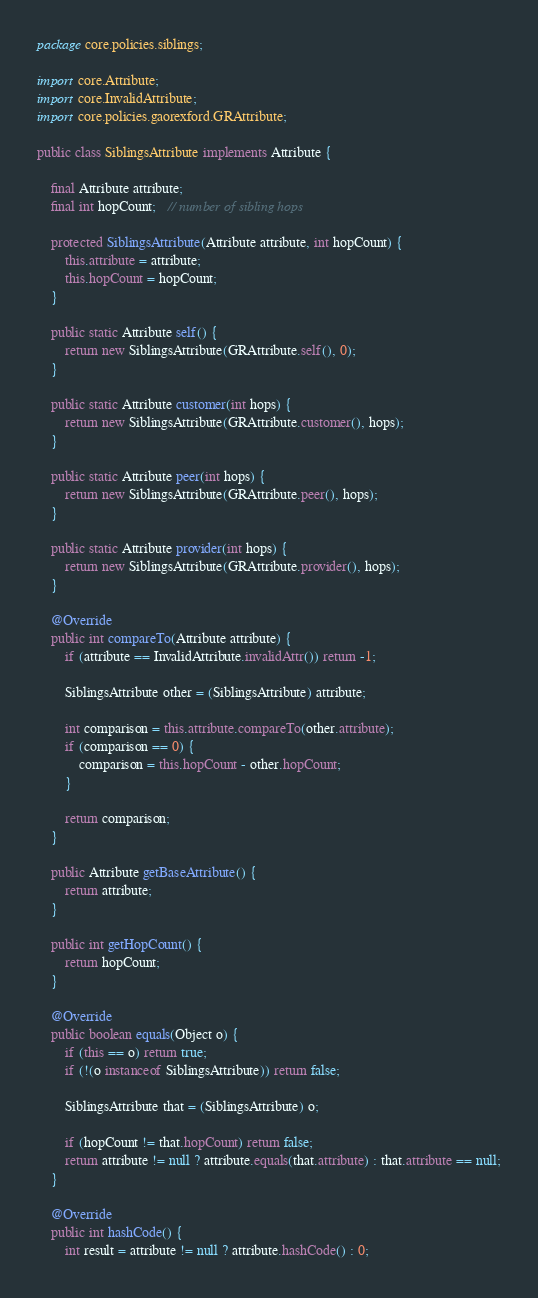Convert code to text. <code><loc_0><loc_0><loc_500><loc_500><_Java_>package core.policies.siblings;

import core.Attribute;
import core.InvalidAttribute;
import core.policies.gaorexford.GRAttribute;

public class SiblingsAttribute implements Attribute {

    final Attribute attribute;
    final int hopCount;   // number of sibling hops

    protected SiblingsAttribute(Attribute attribute, int hopCount) {
        this.attribute = attribute;
        this.hopCount = hopCount;
    }

    public static Attribute self() {
        return new SiblingsAttribute(GRAttribute.self(), 0);
    }

    public static Attribute customer(int hops) {
        return new SiblingsAttribute(GRAttribute.customer(), hops);
    }

    public static Attribute peer(int hops) {
        return new SiblingsAttribute(GRAttribute.peer(), hops);
    }

    public static Attribute provider(int hops) {
        return new SiblingsAttribute(GRAttribute.provider(), hops);
    }

    @Override
    public int compareTo(Attribute attribute) {
        if (attribute == InvalidAttribute.invalidAttr()) return -1;

        SiblingsAttribute other = (SiblingsAttribute) attribute;

        int comparison = this.attribute.compareTo(other.attribute);
        if (comparison == 0) {
            comparison = this.hopCount - other.hopCount;
        }

        return comparison;
    }

    public Attribute getBaseAttribute() {
        return attribute;
    }

    public int getHopCount() {
        return hopCount;
    }

    @Override
    public boolean equals(Object o) {
        if (this == o) return true;
        if (!(o instanceof SiblingsAttribute)) return false;

        SiblingsAttribute that = (SiblingsAttribute) o;

        if (hopCount != that.hopCount) return false;
        return attribute != null ? attribute.equals(that.attribute) : that.attribute == null;
    }

    @Override
    public int hashCode() {
        int result = attribute != null ? attribute.hashCode() : 0;</code> 